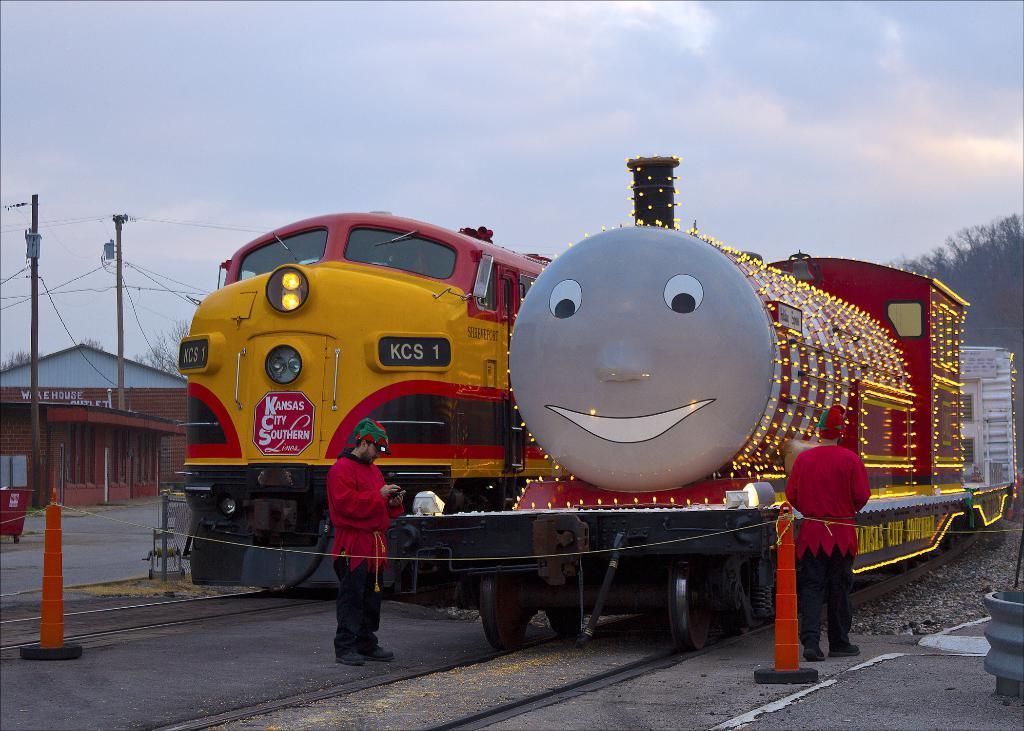Can you describe this image briefly? In this image in the center there are trains on the railway track. On the right side there is a train which is decorated with lights and in front of the train there are persons standing. On the left side there is a building and in front of the building there are poles with wires attached to it and on the right side in the background there is a tree and the sky is cloudy. 